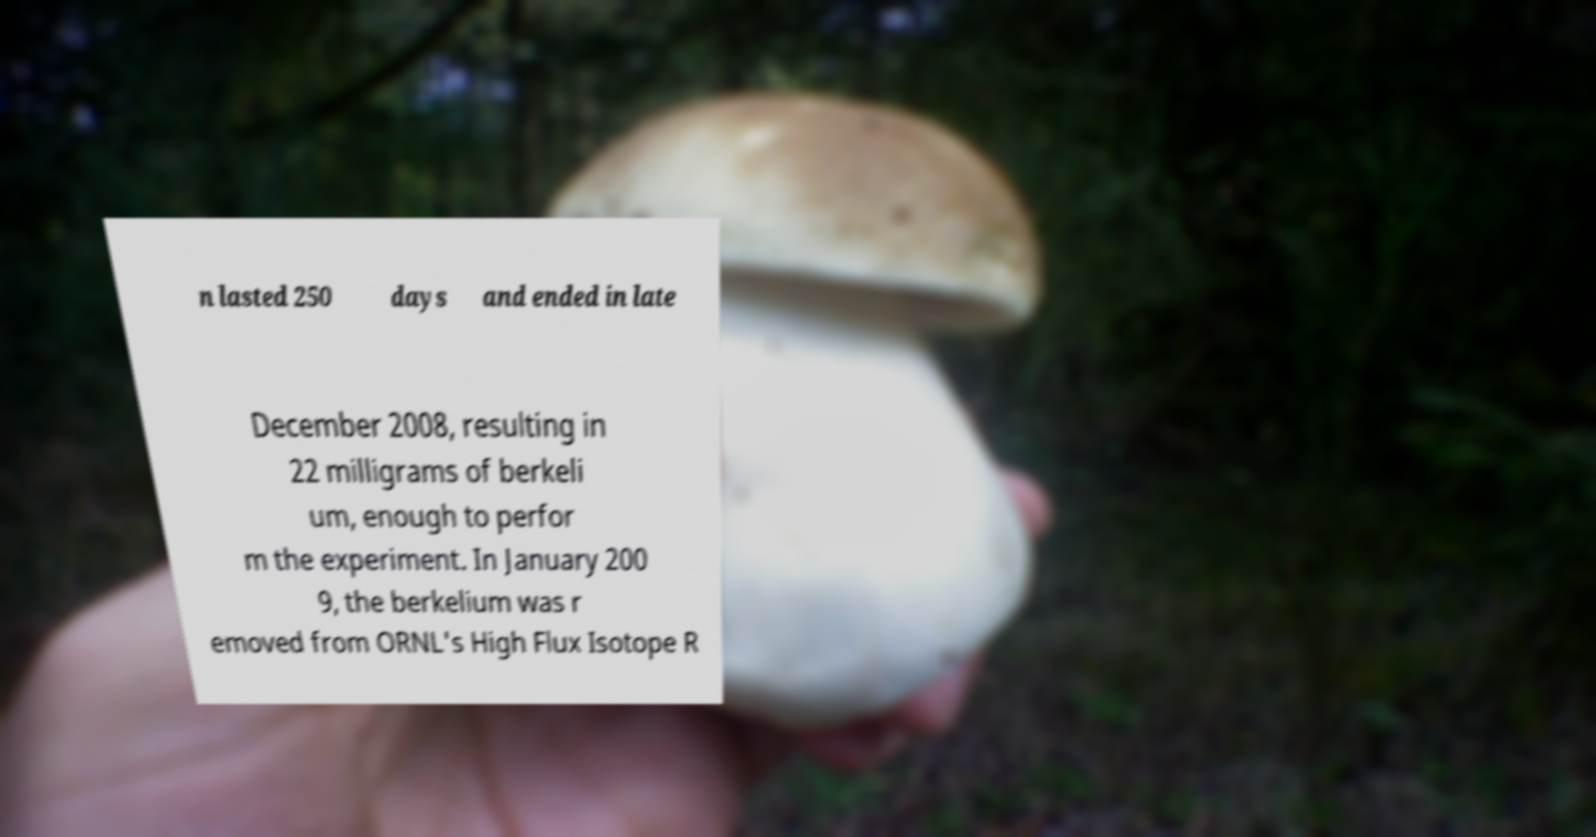Please identify and transcribe the text found in this image. n lasted 250 days and ended in late December 2008, resulting in 22 milligrams of berkeli um, enough to perfor m the experiment. In January 200 9, the berkelium was r emoved from ORNL's High Flux Isotope R 